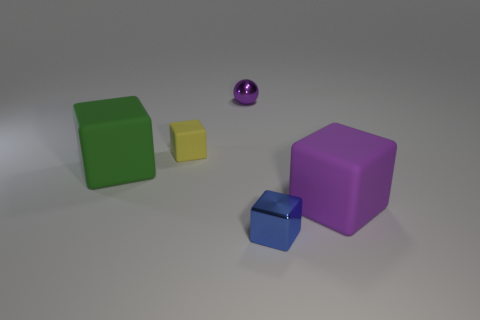What kind of mood does the lighting in this image evoke? The soft lighting with a gentle gradient across the surface and subtle highlights on the objects give the image a calm and serene mood. There is a sense of quiet stillness that is almost contemplative. Could the lighting also influence the perceived weight and stability of the objects? Indeed, lighting can affect perceptions of weight and stability. Well-defined shadows and highlights suggest solidity and weight, while a more diffuse light might make the objects appear lighter. In this image, the clear shadows and soft highlights help the objects appear stable and firmly placed within the scene. 